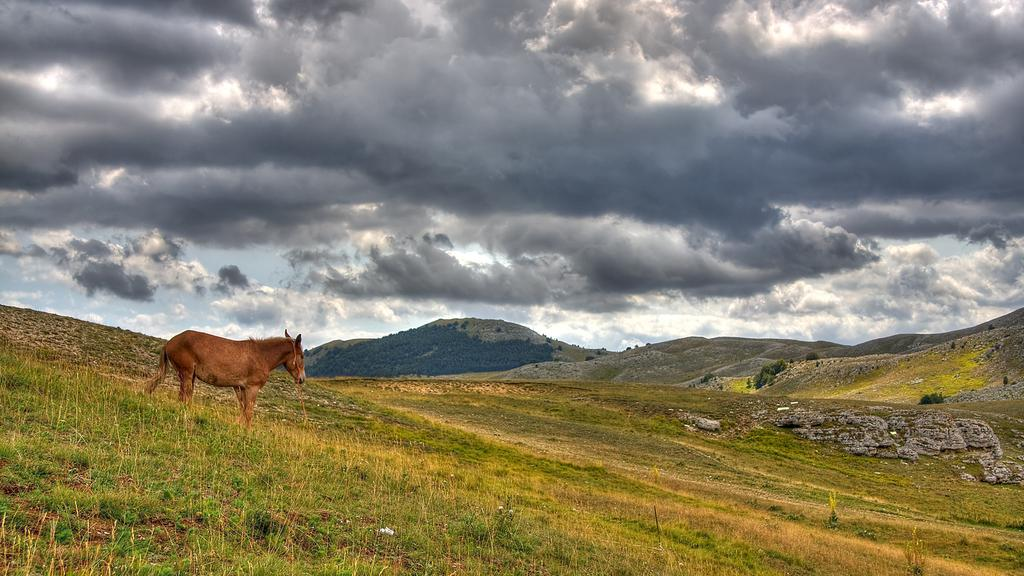What animal can be seen in the image? There is a horse standing on the grass in the image. What type of terrain is visible in the image? Hills are visible in the image. What other natural elements can be seen in the image? There are trees in the image. What is visible in the background of the image? The sky is visible in the background of the image. What can be observed in the sky? Clouds are present in the sky. Where is the match being used in the image? There is no match present in the image. What type of rock is the horse standing on in the image? The horse is standing on grass, not rock, in the image. 